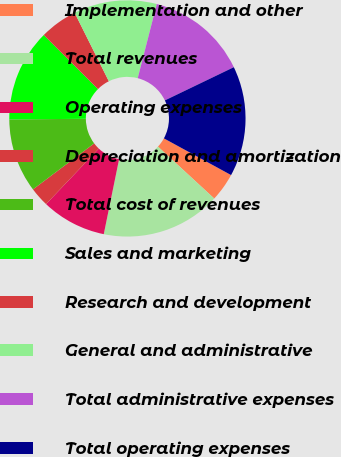Convert chart. <chart><loc_0><loc_0><loc_500><loc_500><pie_chart><fcel>Implementation and other<fcel>Total revenues<fcel>Operating expenses<fcel>Depreciation and amortization<fcel>Total cost of revenues<fcel>Sales and marketing<fcel>Research and development<fcel>General and administrative<fcel>Total administrative expenses<fcel>Total operating expenses<nl><fcel>3.9%<fcel>16.35%<fcel>8.88%<fcel>2.66%<fcel>10.12%<fcel>12.61%<fcel>5.15%<fcel>11.37%<fcel>13.86%<fcel>15.1%<nl></chart> 